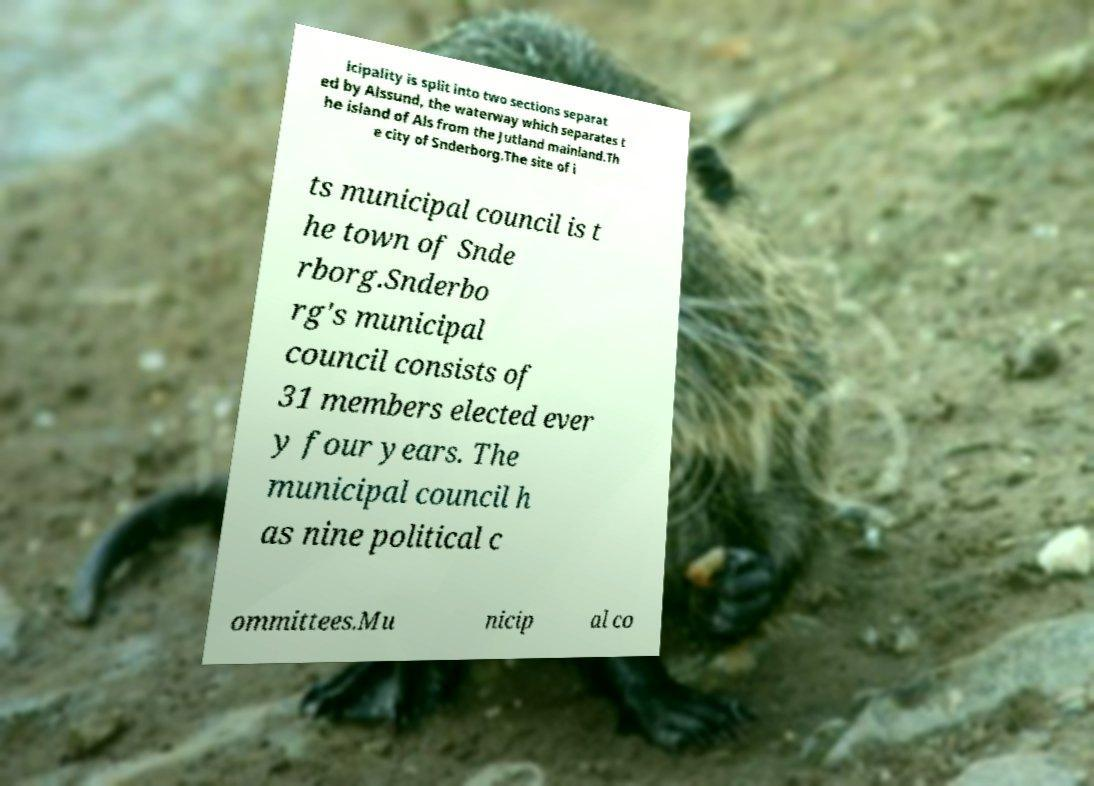Please identify and transcribe the text found in this image. icipality is split into two sections separat ed by Alssund, the waterway which separates t he island of Als from the Jutland mainland.Th e city of Snderborg.The site of i ts municipal council is t he town of Snde rborg.Snderbo rg's municipal council consists of 31 members elected ever y four years. The municipal council h as nine political c ommittees.Mu nicip al co 